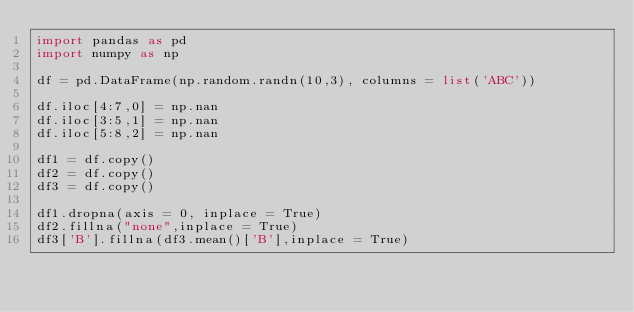Convert code to text. <code><loc_0><loc_0><loc_500><loc_500><_Python_>import pandas as pd
import numpy as np

df = pd.DataFrame(np.random.randn(10,3), columns = list('ABC'))

df.iloc[4:7,0] = np.nan
df.iloc[3:5,1] = np.nan
df.iloc[5:8,2] = np.nan

df1 = df.copy()
df2 = df.copy()
df3 = df.copy()

df1.dropna(axis = 0, inplace = True)
df2.fillna("none",inplace = True)
df3['B'].fillna(df3.mean()['B'],inplace = True)</code> 